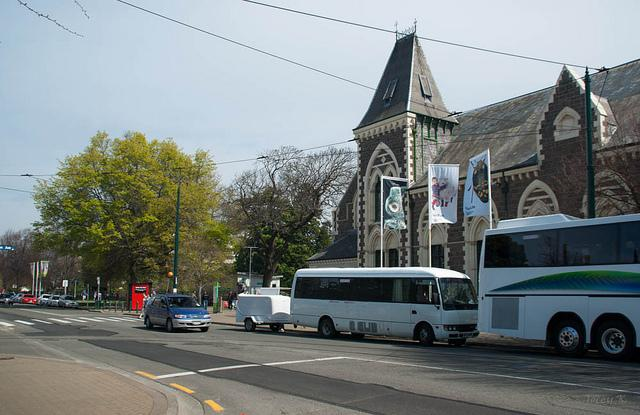What are these banners promoting?

Choices:
A) dance halls
B) museums
C) open houses
D) church museums 